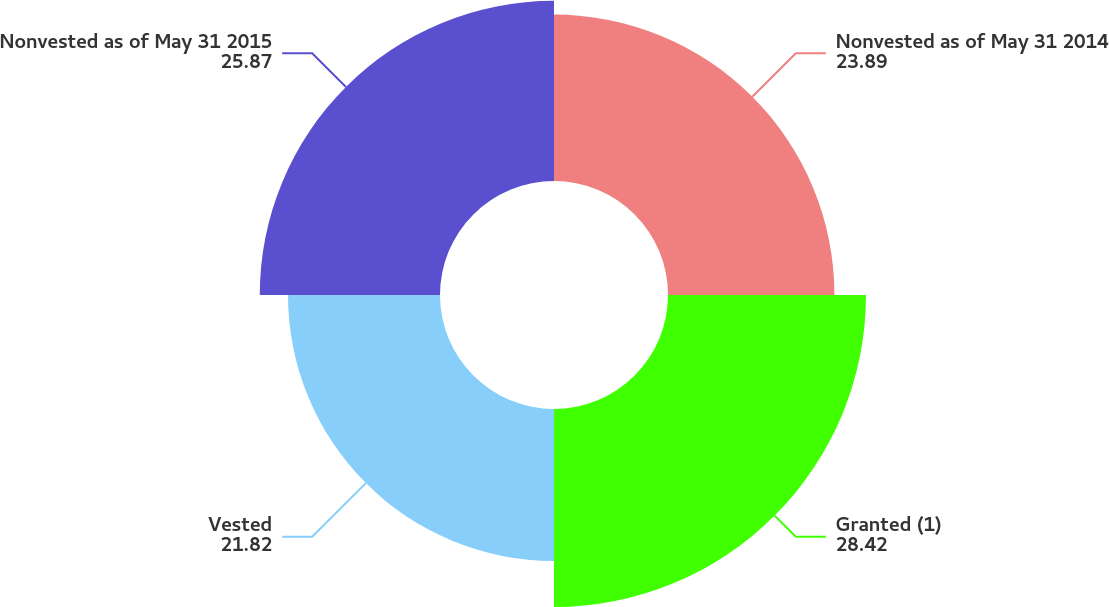Convert chart. <chart><loc_0><loc_0><loc_500><loc_500><pie_chart><fcel>Nonvested as of May 31 2014<fcel>Granted (1)<fcel>Vested<fcel>Nonvested as of May 31 2015<nl><fcel>23.89%<fcel>28.42%<fcel>21.82%<fcel>25.87%<nl></chart> 